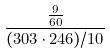Convert formula to latex. <formula><loc_0><loc_0><loc_500><loc_500>\frac { \frac { 9 } { 6 0 } } { ( 3 0 3 \cdot 2 4 6 ) / 1 0 }</formula> 